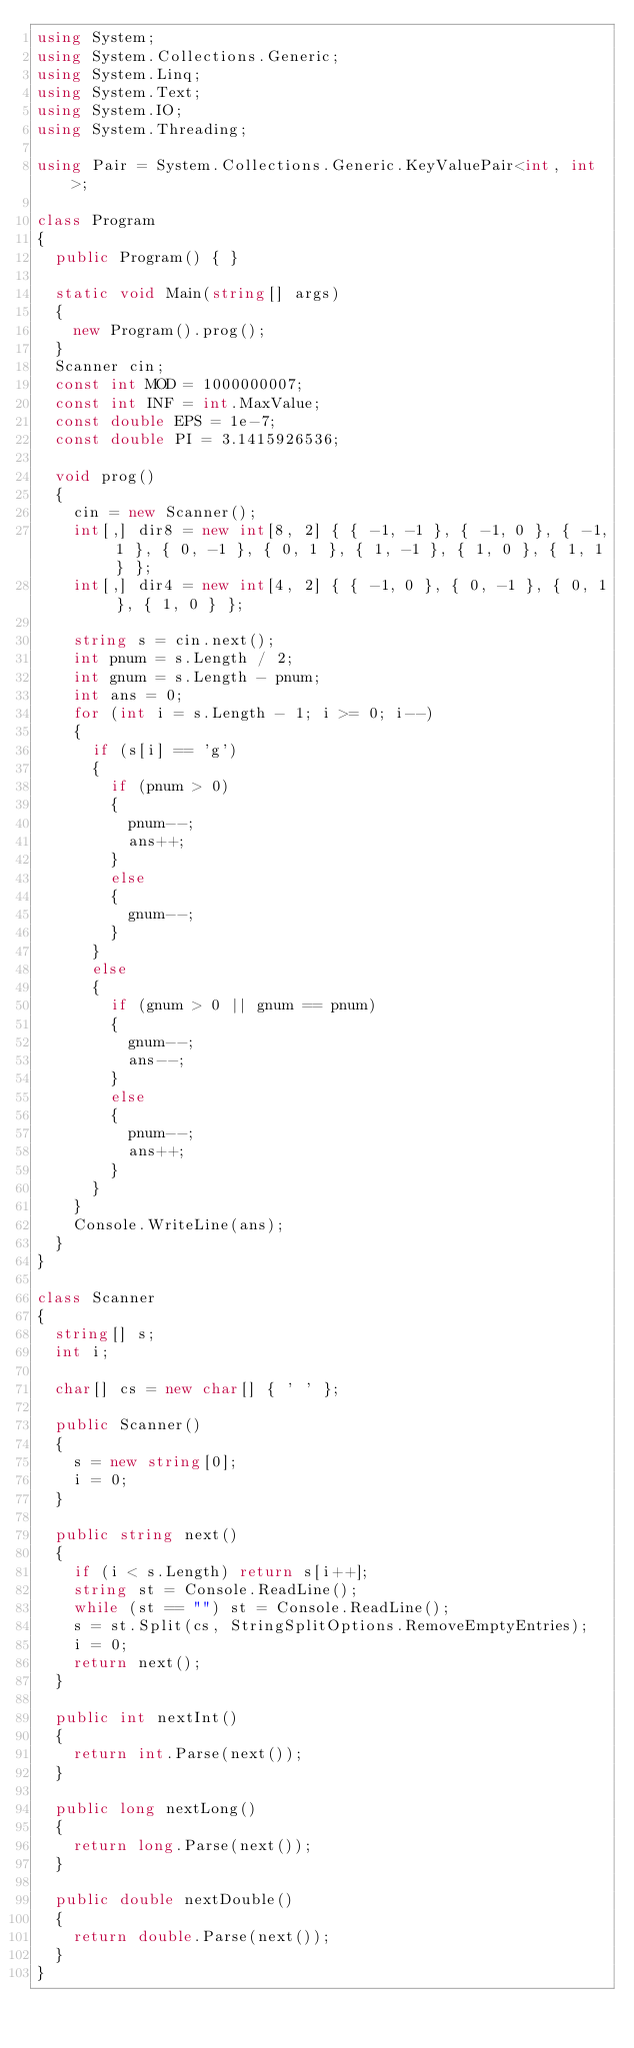Convert code to text. <code><loc_0><loc_0><loc_500><loc_500><_C#_>using System;
using System.Collections.Generic;
using System.Linq;
using System.Text;
using System.IO;
using System.Threading;

using Pair = System.Collections.Generic.KeyValuePair<int, int>;

class Program
{
	public Program() { }

	static void Main(string[] args)
	{
		new Program().prog();
	}
	Scanner cin;
	const int MOD = 1000000007;
	const int INF = int.MaxValue;
	const double EPS = 1e-7;
	const double PI = 3.1415926536;

	void prog()
	{
		cin = new Scanner();
		int[,] dir8 = new int[8, 2] { { -1, -1 }, { -1, 0 }, { -1, 1 }, { 0, -1 }, { 0, 1 }, { 1, -1 }, { 1, 0 }, { 1, 1 } };
		int[,] dir4 = new int[4, 2] { { -1, 0 }, { 0, -1 }, { 0, 1 }, { 1, 0 } };

		string s = cin.next();
		int pnum = s.Length / 2;
		int gnum = s.Length - pnum;
		int ans = 0;
		for (int i = s.Length - 1; i >= 0; i--)
		{
			if (s[i] == 'g')
			{
				if (pnum > 0)
				{
					pnum--;
					ans++;
				}
				else
				{
					gnum--;
				}
			}
			else
			{
				if (gnum > 0 || gnum == pnum)
				{
					gnum--;
					ans--;
				}
				else
				{
					pnum--;
					ans++;
				}
			}
		}
		Console.WriteLine(ans);
	}
}

class Scanner
{
	string[] s;
	int i;

	char[] cs = new char[] { ' ' };

	public Scanner()
	{
		s = new string[0];
		i = 0;
	}

	public string next()
	{
		if (i < s.Length) return s[i++];
		string st = Console.ReadLine();
		while (st == "") st = Console.ReadLine();
		s = st.Split(cs, StringSplitOptions.RemoveEmptyEntries);
		i = 0;
		return next();
	}

	public int nextInt()
	{
		return int.Parse(next());
	}

	public long nextLong()
	{
		return long.Parse(next());
	}

	public double nextDouble()
	{
		return double.Parse(next());
	}
}</code> 